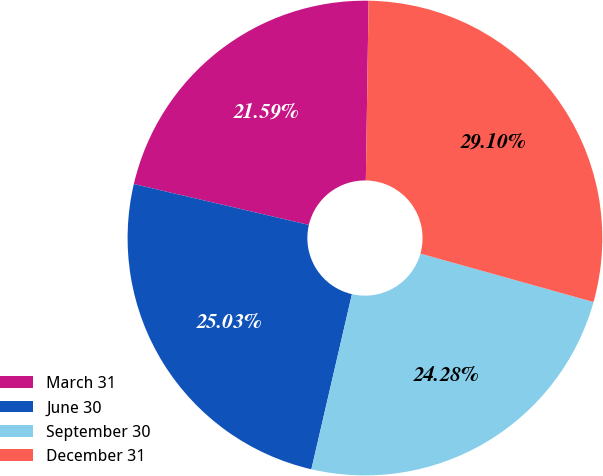Convert chart to OTSL. <chart><loc_0><loc_0><loc_500><loc_500><pie_chart><fcel>March 31<fcel>June 30<fcel>September 30<fcel>December 31<nl><fcel>21.59%<fcel>25.03%<fcel>24.28%<fcel>29.1%<nl></chart> 